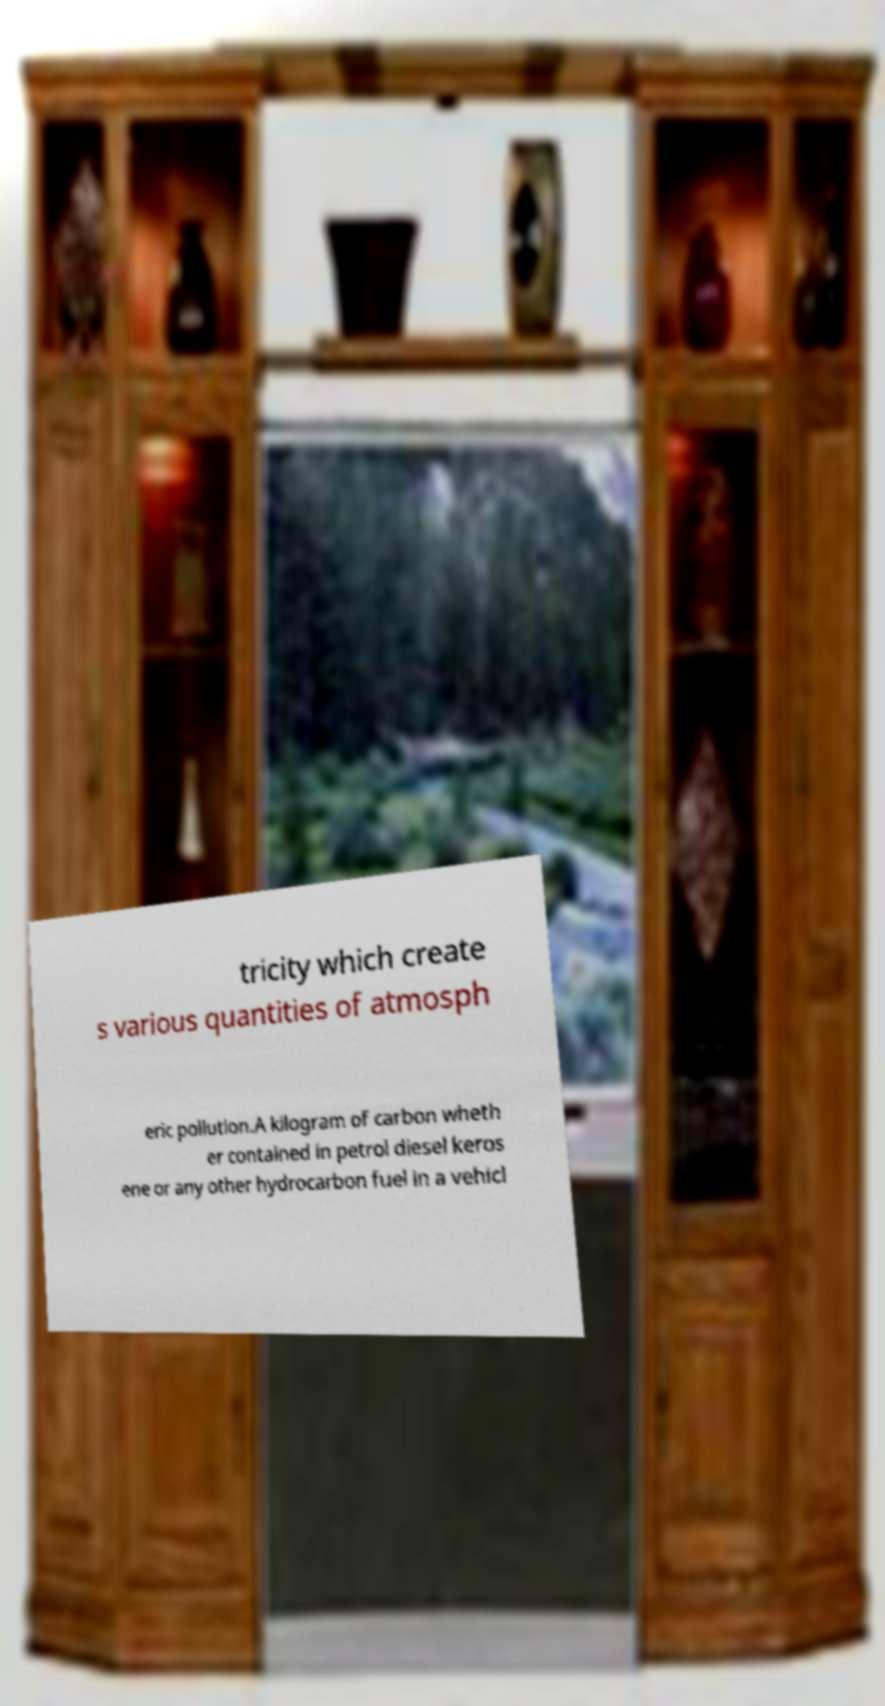Can you read and provide the text displayed in the image?This photo seems to have some interesting text. Can you extract and type it out for me? tricity which create s various quantities of atmosph eric pollution.A kilogram of carbon wheth er contained in petrol diesel keros ene or any other hydrocarbon fuel in a vehicl 